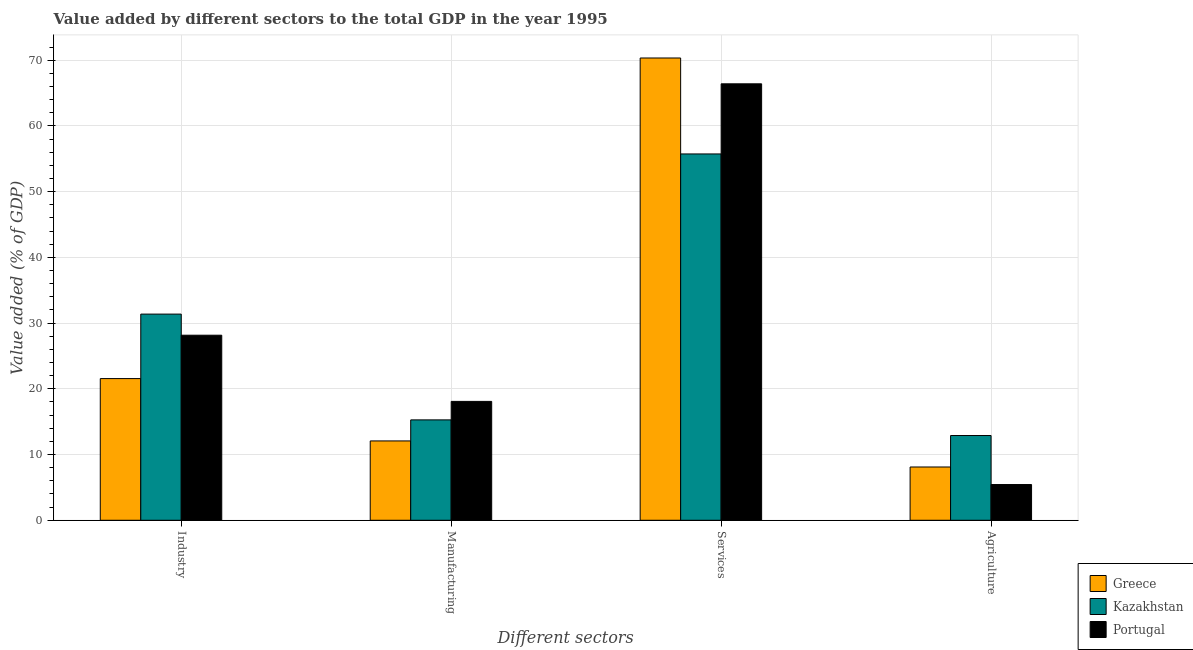How many different coloured bars are there?
Your response must be concise. 3. How many groups of bars are there?
Your answer should be compact. 4. Are the number of bars on each tick of the X-axis equal?
Make the answer very short. Yes. How many bars are there on the 4th tick from the left?
Give a very brief answer. 3. What is the label of the 1st group of bars from the left?
Ensure brevity in your answer.  Industry. What is the value added by services sector in Kazakhstan?
Keep it short and to the point. 55.74. Across all countries, what is the maximum value added by manufacturing sector?
Provide a succinct answer. 18.09. Across all countries, what is the minimum value added by manufacturing sector?
Provide a succinct answer. 12.07. In which country was the value added by services sector maximum?
Keep it short and to the point. Greece. In which country was the value added by industrial sector minimum?
Make the answer very short. Greece. What is the total value added by agricultural sector in the graph?
Offer a terse response. 26.43. What is the difference between the value added by agricultural sector in Greece and that in Kazakhstan?
Provide a succinct answer. -4.79. What is the difference between the value added by agricultural sector in Kazakhstan and the value added by industrial sector in Greece?
Provide a short and direct response. -8.66. What is the average value added by services sector per country?
Your response must be concise. 64.16. What is the difference between the value added by manufacturing sector and value added by industrial sector in Kazakhstan?
Your answer should be compact. -16.09. In how many countries, is the value added by manufacturing sector greater than 46 %?
Offer a very short reply. 0. What is the ratio of the value added by agricultural sector in Greece to that in Portugal?
Provide a short and direct response. 1.49. Is the difference between the value added by agricultural sector in Kazakhstan and Portugal greater than the difference between the value added by manufacturing sector in Kazakhstan and Portugal?
Provide a short and direct response. Yes. What is the difference between the highest and the second highest value added by agricultural sector?
Ensure brevity in your answer.  4.79. What is the difference between the highest and the lowest value added by industrial sector?
Offer a very short reply. 9.81. In how many countries, is the value added by agricultural sector greater than the average value added by agricultural sector taken over all countries?
Your response must be concise. 1. Is the sum of the value added by agricultural sector in Portugal and Greece greater than the maximum value added by industrial sector across all countries?
Provide a short and direct response. No. How many bars are there?
Your response must be concise. 12. Are all the bars in the graph horizontal?
Make the answer very short. No. How many legend labels are there?
Keep it short and to the point. 3. How are the legend labels stacked?
Offer a terse response. Vertical. What is the title of the graph?
Your answer should be very brief. Value added by different sectors to the total GDP in the year 1995. What is the label or title of the X-axis?
Give a very brief answer. Different sectors. What is the label or title of the Y-axis?
Keep it short and to the point. Value added (% of GDP). What is the Value added (% of GDP) in Greece in Industry?
Offer a terse response. 21.56. What is the Value added (% of GDP) in Kazakhstan in Industry?
Keep it short and to the point. 31.37. What is the Value added (% of GDP) of Portugal in Industry?
Your answer should be very brief. 28.16. What is the Value added (% of GDP) in Greece in Manufacturing?
Make the answer very short. 12.07. What is the Value added (% of GDP) in Kazakhstan in Manufacturing?
Provide a short and direct response. 15.27. What is the Value added (% of GDP) of Portugal in Manufacturing?
Keep it short and to the point. 18.09. What is the Value added (% of GDP) of Greece in Services?
Your answer should be compact. 70.34. What is the Value added (% of GDP) in Kazakhstan in Services?
Offer a very short reply. 55.74. What is the Value added (% of GDP) in Portugal in Services?
Offer a terse response. 66.41. What is the Value added (% of GDP) of Greece in Agriculture?
Provide a short and direct response. 8.11. What is the Value added (% of GDP) in Kazakhstan in Agriculture?
Offer a terse response. 12.89. What is the Value added (% of GDP) in Portugal in Agriculture?
Your answer should be very brief. 5.44. Across all Different sectors, what is the maximum Value added (% of GDP) in Greece?
Your response must be concise. 70.34. Across all Different sectors, what is the maximum Value added (% of GDP) in Kazakhstan?
Make the answer very short. 55.74. Across all Different sectors, what is the maximum Value added (% of GDP) in Portugal?
Offer a terse response. 66.41. Across all Different sectors, what is the minimum Value added (% of GDP) of Greece?
Provide a short and direct response. 8.11. Across all Different sectors, what is the minimum Value added (% of GDP) in Kazakhstan?
Your response must be concise. 12.89. Across all Different sectors, what is the minimum Value added (% of GDP) in Portugal?
Offer a terse response. 5.44. What is the total Value added (% of GDP) in Greece in the graph?
Make the answer very short. 112.07. What is the total Value added (% of GDP) of Kazakhstan in the graph?
Provide a succinct answer. 115.27. What is the total Value added (% of GDP) in Portugal in the graph?
Your answer should be compact. 118.09. What is the difference between the Value added (% of GDP) in Greece in Industry and that in Manufacturing?
Make the answer very short. 9.49. What is the difference between the Value added (% of GDP) in Kazakhstan in Industry and that in Manufacturing?
Keep it short and to the point. 16.09. What is the difference between the Value added (% of GDP) of Portugal in Industry and that in Manufacturing?
Provide a succinct answer. 10.07. What is the difference between the Value added (% of GDP) in Greece in Industry and that in Services?
Your response must be concise. -48.78. What is the difference between the Value added (% of GDP) of Kazakhstan in Industry and that in Services?
Make the answer very short. -24.37. What is the difference between the Value added (% of GDP) in Portugal in Industry and that in Services?
Your answer should be compact. -38.25. What is the difference between the Value added (% of GDP) of Greece in Industry and that in Agriculture?
Provide a short and direct response. 13.45. What is the difference between the Value added (% of GDP) in Kazakhstan in Industry and that in Agriculture?
Your response must be concise. 18.48. What is the difference between the Value added (% of GDP) in Portugal in Industry and that in Agriculture?
Ensure brevity in your answer.  22.72. What is the difference between the Value added (% of GDP) of Greece in Manufacturing and that in Services?
Offer a very short reply. -58.27. What is the difference between the Value added (% of GDP) in Kazakhstan in Manufacturing and that in Services?
Offer a very short reply. -40.46. What is the difference between the Value added (% of GDP) in Portugal in Manufacturing and that in Services?
Offer a very short reply. -48.32. What is the difference between the Value added (% of GDP) in Greece in Manufacturing and that in Agriculture?
Provide a short and direct response. 3.97. What is the difference between the Value added (% of GDP) in Kazakhstan in Manufacturing and that in Agriculture?
Provide a succinct answer. 2.38. What is the difference between the Value added (% of GDP) in Portugal in Manufacturing and that in Agriculture?
Offer a terse response. 12.65. What is the difference between the Value added (% of GDP) of Greece in Services and that in Agriculture?
Offer a very short reply. 62.23. What is the difference between the Value added (% of GDP) in Kazakhstan in Services and that in Agriculture?
Provide a short and direct response. 42.85. What is the difference between the Value added (% of GDP) of Portugal in Services and that in Agriculture?
Make the answer very short. 60.97. What is the difference between the Value added (% of GDP) of Greece in Industry and the Value added (% of GDP) of Kazakhstan in Manufacturing?
Your response must be concise. 6.28. What is the difference between the Value added (% of GDP) in Greece in Industry and the Value added (% of GDP) in Portugal in Manufacturing?
Ensure brevity in your answer.  3.47. What is the difference between the Value added (% of GDP) of Kazakhstan in Industry and the Value added (% of GDP) of Portugal in Manufacturing?
Offer a terse response. 13.28. What is the difference between the Value added (% of GDP) in Greece in Industry and the Value added (% of GDP) in Kazakhstan in Services?
Your answer should be compact. -34.18. What is the difference between the Value added (% of GDP) in Greece in Industry and the Value added (% of GDP) in Portugal in Services?
Make the answer very short. -44.85. What is the difference between the Value added (% of GDP) of Kazakhstan in Industry and the Value added (% of GDP) of Portugal in Services?
Make the answer very short. -35.04. What is the difference between the Value added (% of GDP) of Greece in Industry and the Value added (% of GDP) of Kazakhstan in Agriculture?
Ensure brevity in your answer.  8.66. What is the difference between the Value added (% of GDP) in Greece in Industry and the Value added (% of GDP) in Portugal in Agriculture?
Ensure brevity in your answer.  16.12. What is the difference between the Value added (% of GDP) in Kazakhstan in Industry and the Value added (% of GDP) in Portugal in Agriculture?
Make the answer very short. 25.93. What is the difference between the Value added (% of GDP) of Greece in Manufacturing and the Value added (% of GDP) of Kazakhstan in Services?
Keep it short and to the point. -43.67. What is the difference between the Value added (% of GDP) of Greece in Manufacturing and the Value added (% of GDP) of Portugal in Services?
Make the answer very short. -54.34. What is the difference between the Value added (% of GDP) of Kazakhstan in Manufacturing and the Value added (% of GDP) of Portugal in Services?
Your answer should be very brief. -51.13. What is the difference between the Value added (% of GDP) of Greece in Manufacturing and the Value added (% of GDP) of Kazakhstan in Agriculture?
Your response must be concise. -0.82. What is the difference between the Value added (% of GDP) in Greece in Manufacturing and the Value added (% of GDP) in Portugal in Agriculture?
Keep it short and to the point. 6.64. What is the difference between the Value added (% of GDP) in Kazakhstan in Manufacturing and the Value added (% of GDP) in Portugal in Agriculture?
Your answer should be compact. 9.84. What is the difference between the Value added (% of GDP) in Greece in Services and the Value added (% of GDP) in Kazakhstan in Agriculture?
Give a very brief answer. 57.44. What is the difference between the Value added (% of GDP) in Greece in Services and the Value added (% of GDP) in Portugal in Agriculture?
Your answer should be compact. 64.9. What is the difference between the Value added (% of GDP) of Kazakhstan in Services and the Value added (% of GDP) of Portugal in Agriculture?
Your answer should be compact. 50.3. What is the average Value added (% of GDP) of Greece per Different sectors?
Offer a very short reply. 28.02. What is the average Value added (% of GDP) in Kazakhstan per Different sectors?
Your answer should be very brief. 28.82. What is the average Value added (% of GDP) of Portugal per Different sectors?
Your answer should be compact. 29.52. What is the difference between the Value added (% of GDP) in Greece and Value added (% of GDP) in Kazakhstan in Industry?
Offer a very short reply. -9.81. What is the difference between the Value added (% of GDP) in Greece and Value added (% of GDP) in Portugal in Industry?
Offer a terse response. -6.6. What is the difference between the Value added (% of GDP) in Kazakhstan and Value added (% of GDP) in Portugal in Industry?
Give a very brief answer. 3.21. What is the difference between the Value added (% of GDP) in Greece and Value added (% of GDP) in Kazakhstan in Manufacturing?
Ensure brevity in your answer.  -3.2. What is the difference between the Value added (% of GDP) in Greece and Value added (% of GDP) in Portugal in Manufacturing?
Your response must be concise. -6.01. What is the difference between the Value added (% of GDP) of Kazakhstan and Value added (% of GDP) of Portugal in Manufacturing?
Keep it short and to the point. -2.81. What is the difference between the Value added (% of GDP) in Greece and Value added (% of GDP) in Kazakhstan in Services?
Make the answer very short. 14.6. What is the difference between the Value added (% of GDP) of Greece and Value added (% of GDP) of Portugal in Services?
Give a very brief answer. 3.93. What is the difference between the Value added (% of GDP) of Kazakhstan and Value added (% of GDP) of Portugal in Services?
Provide a short and direct response. -10.67. What is the difference between the Value added (% of GDP) in Greece and Value added (% of GDP) in Kazakhstan in Agriculture?
Provide a succinct answer. -4.79. What is the difference between the Value added (% of GDP) in Greece and Value added (% of GDP) in Portugal in Agriculture?
Offer a very short reply. 2.67. What is the difference between the Value added (% of GDP) in Kazakhstan and Value added (% of GDP) in Portugal in Agriculture?
Ensure brevity in your answer.  7.46. What is the ratio of the Value added (% of GDP) of Greece in Industry to that in Manufacturing?
Ensure brevity in your answer.  1.79. What is the ratio of the Value added (% of GDP) of Kazakhstan in Industry to that in Manufacturing?
Give a very brief answer. 2.05. What is the ratio of the Value added (% of GDP) in Portugal in Industry to that in Manufacturing?
Your response must be concise. 1.56. What is the ratio of the Value added (% of GDP) of Greece in Industry to that in Services?
Keep it short and to the point. 0.31. What is the ratio of the Value added (% of GDP) of Kazakhstan in Industry to that in Services?
Provide a short and direct response. 0.56. What is the ratio of the Value added (% of GDP) in Portugal in Industry to that in Services?
Offer a terse response. 0.42. What is the ratio of the Value added (% of GDP) in Greece in Industry to that in Agriculture?
Provide a succinct answer. 2.66. What is the ratio of the Value added (% of GDP) of Kazakhstan in Industry to that in Agriculture?
Your answer should be compact. 2.43. What is the ratio of the Value added (% of GDP) of Portugal in Industry to that in Agriculture?
Make the answer very short. 5.18. What is the ratio of the Value added (% of GDP) of Greece in Manufacturing to that in Services?
Your answer should be very brief. 0.17. What is the ratio of the Value added (% of GDP) of Kazakhstan in Manufacturing to that in Services?
Offer a terse response. 0.27. What is the ratio of the Value added (% of GDP) of Portugal in Manufacturing to that in Services?
Give a very brief answer. 0.27. What is the ratio of the Value added (% of GDP) of Greece in Manufacturing to that in Agriculture?
Your response must be concise. 1.49. What is the ratio of the Value added (% of GDP) of Kazakhstan in Manufacturing to that in Agriculture?
Your response must be concise. 1.18. What is the ratio of the Value added (% of GDP) of Portugal in Manufacturing to that in Agriculture?
Offer a very short reply. 3.33. What is the ratio of the Value added (% of GDP) of Greece in Services to that in Agriculture?
Ensure brevity in your answer.  8.68. What is the ratio of the Value added (% of GDP) of Kazakhstan in Services to that in Agriculture?
Your answer should be compact. 4.32. What is the ratio of the Value added (% of GDP) in Portugal in Services to that in Agriculture?
Offer a terse response. 12.22. What is the difference between the highest and the second highest Value added (% of GDP) in Greece?
Give a very brief answer. 48.78. What is the difference between the highest and the second highest Value added (% of GDP) of Kazakhstan?
Ensure brevity in your answer.  24.37. What is the difference between the highest and the second highest Value added (% of GDP) in Portugal?
Provide a succinct answer. 38.25. What is the difference between the highest and the lowest Value added (% of GDP) of Greece?
Give a very brief answer. 62.23. What is the difference between the highest and the lowest Value added (% of GDP) in Kazakhstan?
Your answer should be very brief. 42.85. What is the difference between the highest and the lowest Value added (% of GDP) of Portugal?
Give a very brief answer. 60.97. 